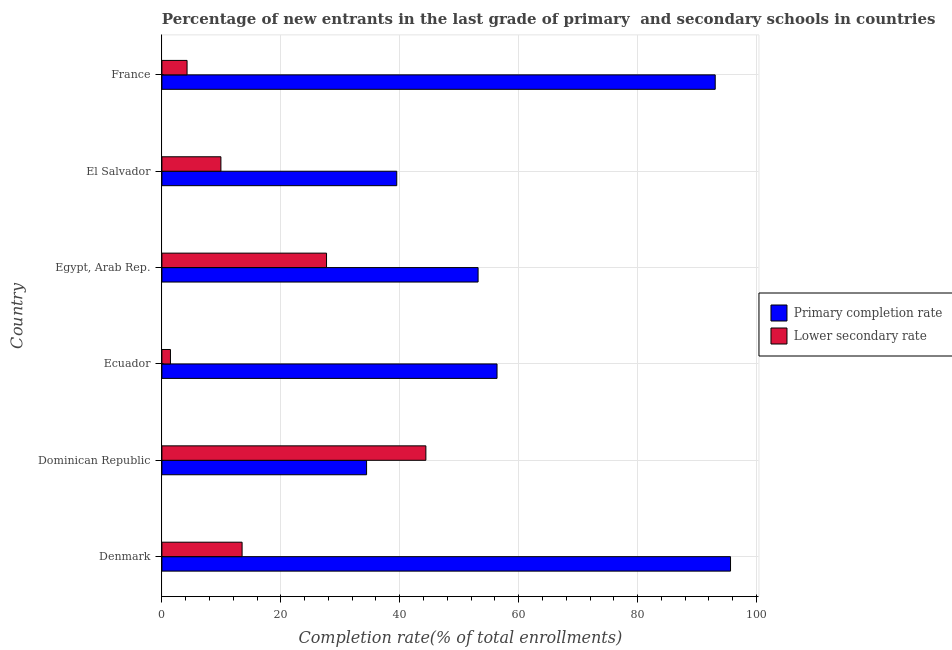How many different coloured bars are there?
Provide a short and direct response. 2. How many groups of bars are there?
Offer a very short reply. 6. Are the number of bars per tick equal to the number of legend labels?
Your answer should be very brief. Yes. What is the completion rate in primary schools in Dominican Republic?
Ensure brevity in your answer.  34.42. Across all countries, what is the maximum completion rate in secondary schools?
Your answer should be very brief. 44.39. Across all countries, what is the minimum completion rate in primary schools?
Your response must be concise. 34.42. In which country was the completion rate in secondary schools maximum?
Your answer should be compact. Dominican Republic. In which country was the completion rate in primary schools minimum?
Offer a terse response. Dominican Republic. What is the total completion rate in primary schools in the graph?
Your response must be concise. 372.14. What is the difference between the completion rate in secondary schools in Ecuador and that in France?
Provide a succinct answer. -2.79. What is the difference between the completion rate in secondary schools in El Salvador and the completion rate in primary schools in France?
Give a very brief answer. -83.13. What is the average completion rate in primary schools per country?
Provide a short and direct response. 62.02. What is the difference between the completion rate in primary schools and completion rate in secondary schools in France?
Your answer should be compact. 88.83. In how many countries, is the completion rate in secondary schools greater than 20 %?
Your response must be concise. 2. What is the ratio of the completion rate in primary schools in Ecuador to that in France?
Your response must be concise. 0.61. Is the completion rate in secondary schools in Ecuador less than that in France?
Your answer should be compact. Yes. What is the difference between the highest and the second highest completion rate in primary schools?
Offer a terse response. 2.58. What is the difference between the highest and the lowest completion rate in primary schools?
Your response must be concise. 61.21. In how many countries, is the completion rate in primary schools greater than the average completion rate in primary schools taken over all countries?
Ensure brevity in your answer.  2. Is the sum of the completion rate in secondary schools in Dominican Republic and Egypt, Arab Rep. greater than the maximum completion rate in primary schools across all countries?
Offer a terse response. No. What does the 1st bar from the top in El Salvador represents?
Make the answer very short. Lower secondary rate. What does the 1st bar from the bottom in Dominican Republic represents?
Offer a terse response. Primary completion rate. How many countries are there in the graph?
Provide a short and direct response. 6. What is the difference between two consecutive major ticks on the X-axis?
Give a very brief answer. 20. Are the values on the major ticks of X-axis written in scientific E-notation?
Give a very brief answer. No. How many legend labels are there?
Give a very brief answer. 2. What is the title of the graph?
Offer a terse response. Percentage of new entrants in the last grade of primary  and secondary schools in countries. Does "Working capital" appear as one of the legend labels in the graph?
Your response must be concise. No. What is the label or title of the X-axis?
Provide a succinct answer. Completion rate(% of total enrollments). What is the Completion rate(% of total enrollments) in Primary completion rate in Denmark?
Your answer should be very brief. 95.63. What is the Completion rate(% of total enrollments) in Lower secondary rate in Denmark?
Your answer should be compact. 13.49. What is the Completion rate(% of total enrollments) in Primary completion rate in Dominican Republic?
Make the answer very short. 34.42. What is the Completion rate(% of total enrollments) in Lower secondary rate in Dominican Republic?
Ensure brevity in your answer.  44.39. What is the Completion rate(% of total enrollments) in Primary completion rate in Ecuador?
Your answer should be compact. 56.36. What is the Completion rate(% of total enrollments) in Lower secondary rate in Ecuador?
Offer a very short reply. 1.44. What is the Completion rate(% of total enrollments) in Primary completion rate in Egypt, Arab Rep.?
Your answer should be very brief. 53.18. What is the Completion rate(% of total enrollments) in Lower secondary rate in Egypt, Arab Rep.?
Offer a very short reply. 27.69. What is the Completion rate(% of total enrollments) of Primary completion rate in El Salvador?
Offer a terse response. 39.5. What is the Completion rate(% of total enrollments) of Lower secondary rate in El Salvador?
Provide a succinct answer. 9.92. What is the Completion rate(% of total enrollments) of Primary completion rate in France?
Make the answer very short. 93.06. What is the Completion rate(% of total enrollments) in Lower secondary rate in France?
Provide a short and direct response. 4.23. Across all countries, what is the maximum Completion rate(% of total enrollments) of Primary completion rate?
Your answer should be very brief. 95.63. Across all countries, what is the maximum Completion rate(% of total enrollments) of Lower secondary rate?
Give a very brief answer. 44.39. Across all countries, what is the minimum Completion rate(% of total enrollments) of Primary completion rate?
Give a very brief answer. 34.42. Across all countries, what is the minimum Completion rate(% of total enrollments) in Lower secondary rate?
Provide a succinct answer. 1.44. What is the total Completion rate(% of total enrollments) of Primary completion rate in the graph?
Provide a succinct answer. 372.14. What is the total Completion rate(% of total enrollments) of Lower secondary rate in the graph?
Make the answer very short. 101.16. What is the difference between the Completion rate(% of total enrollments) of Primary completion rate in Denmark and that in Dominican Republic?
Offer a very short reply. 61.21. What is the difference between the Completion rate(% of total enrollments) of Lower secondary rate in Denmark and that in Dominican Republic?
Provide a short and direct response. -30.91. What is the difference between the Completion rate(% of total enrollments) in Primary completion rate in Denmark and that in Ecuador?
Your response must be concise. 39.27. What is the difference between the Completion rate(% of total enrollments) in Lower secondary rate in Denmark and that in Ecuador?
Your answer should be very brief. 12.05. What is the difference between the Completion rate(% of total enrollments) of Primary completion rate in Denmark and that in Egypt, Arab Rep.?
Give a very brief answer. 42.46. What is the difference between the Completion rate(% of total enrollments) in Lower secondary rate in Denmark and that in Egypt, Arab Rep.?
Offer a terse response. -14.2. What is the difference between the Completion rate(% of total enrollments) in Primary completion rate in Denmark and that in El Salvador?
Provide a succinct answer. 56.13. What is the difference between the Completion rate(% of total enrollments) of Lower secondary rate in Denmark and that in El Salvador?
Your answer should be very brief. 3.56. What is the difference between the Completion rate(% of total enrollments) of Primary completion rate in Denmark and that in France?
Offer a very short reply. 2.57. What is the difference between the Completion rate(% of total enrollments) in Lower secondary rate in Denmark and that in France?
Offer a terse response. 9.25. What is the difference between the Completion rate(% of total enrollments) of Primary completion rate in Dominican Republic and that in Ecuador?
Provide a short and direct response. -21.94. What is the difference between the Completion rate(% of total enrollments) of Lower secondary rate in Dominican Republic and that in Ecuador?
Provide a succinct answer. 42.95. What is the difference between the Completion rate(% of total enrollments) of Primary completion rate in Dominican Republic and that in Egypt, Arab Rep.?
Give a very brief answer. -18.75. What is the difference between the Completion rate(% of total enrollments) in Lower secondary rate in Dominican Republic and that in Egypt, Arab Rep.?
Provide a succinct answer. 16.71. What is the difference between the Completion rate(% of total enrollments) in Primary completion rate in Dominican Republic and that in El Salvador?
Offer a very short reply. -5.07. What is the difference between the Completion rate(% of total enrollments) in Lower secondary rate in Dominican Republic and that in El Salvador?
Provide a succinct answer. 34.47. What is the difference between the Completion rate(% of total enrollments) of Primary completion rate in Dominican Republic and that in France?
Offer a terse response. -58.63. What is the difference between the Completion rate(% of total enrollments) in Lower secondary rate in Dominican Republic and that in France?
Provide a succinct answer. 40.16. What is the difference between the Completion rate(% of total enrollments) in Primary completion rate in Ecuador and that in Egypt, Arab Rep.?
Make the answer very short. 3.18. What is the difference between the Completion rate(% of total enrollments) of Lower secondary rate in Ecuador and that in Egypt, Arab Rep.?
Keep it short and to the point. -26.25. What is the difference between the Completion rate(% of total enrollments) in Primary completion rate in Ecuador and that in El Salvador?
Provide a short and direct response. 16.86. What is the difference between the Completion rate(% of total enrollments) of Lower secondary rate in Ecuador and that in El Salvador?
Your response must be concise. -8.49. What is the difference between the Completion rate(% of total enrollments) of Primary completion rate in Ecuador and that in France?
Make the answer very short. -36.7. What is the difference between the Completion rate(% of total enrollments) in Lower secondary rate in Ecuador and that in France?
Offer a very short reply. -2.79. What is the difference between the Completion rate(% of total enrollments) of Primary completion rate in Egypt, Arab Rep. and that in El Salvador?
Ensure brevity in your answer.  13.68. What is the difference between the Completion rate(% of total enrollments) of Lower secondary rate in Egypt, Arab Rep. and that in El Salvador?
Provide a short and direct response. 17.76. What is the difference between the Completion rate(% of total enrollments) in Primary completion rate in Egypt, Arab Rep. and that in France?
Keep it short and to the point. -39.88. What is the difference between the Completion rate(% of total enrollments) of Lower secondary rate in Egypt, Arab Rep. and that in France?
Your answer should be compact. 23.46. What is the difference between the Completion rate(% of total enrollments) in Primary completion rate in El Salvador and that in France?
Keep it short and to the point. -53.56. What is the difference between the Completion rate(% of total enrollments) in Lower secondary rate in El Salvador and that in France?
Your answer should be very brief. 5.69. What is the difference between the Completion rate(% of total enrollments) of Primary completion rate in Denmark and the Completion rate(% of total enrollments) of Lower secondary rate in Dominican Republic?
Offer a very short reply. 51.24. What is the difference between the Completion rate(% of total enrollments) in Primary completion rate in Denmark and the Completion rate(% of total enrollments) in Lower secondary rate in Ecuador?
Provide a short and direct response. 94.19. What is the difference between the Completion rate(% of total enrollments) of Primary completion rate in Denmark and the Completion rate(% of total enrollments) of Lower secondary rate in Egypt, Arab Rep.?
Your response must be concise. 67.94. What is the difference between the Completion rate(% of total enrollments) of Primary completion rate in Denmark and the Completion rate(% of total enrollments) of Lower secondary rate in El Salvador?
Keep it short and to the point. 85.71. What is the difference between the Completion rate(% of total enrollments) of Primary completion rate in Denmark and the Completion rate(% of total enrollments) of Lower secondary rate in France?
Make the answer very short. 91.4. What is the difference between the Completion rate(% of total enrollments) in Primary completion rate in Dominican Republic and the Completion rate(% of total enrollments) in Lower secondary rate in Ecuador?
Provide a short and direct response. 32.98. What is the difference between the Completion rate(% of total enrollments) of Primary completion rate in Dominican Republic and the Completion rate(% of total enrollments) of Lower secondary rate in Egypt, Arab Rep.?
Ensure brevity in your answer.  6.73. What is the difference between the Completion rate(% of total enrollments) in Primary completion rate in Dominican Republic and the Completion rate(% of total enrollments) in Lower secondary rate in El Salvador?
Keep it short and to the point. 24.5. What is the difference between the Completion rate(% of total enrollments) in Primary completion rate in Dominican Republic and the Completion rate(% of total enrollments) in Lower secondary rate in France?
Ensure brevity in your answer.  30.19. What is the difference between the Completion rate(% of total enrollments) of Primary completion rate in Ecuador and the Completion rate(% of total enrollments) of Lower secondary rate in Egypt, Arab Rep.?
Make the answer very short. 28.67. What is the difference between the Completion rate(% of total enrollments) of Primary completion rate in Ecuador and the Completion rate(% of total enrollments) of Lower secondary rate in El Salvador?
Make the answer very short. 46.44. What is the difference between the Completion rate(% of total enrollments) of Primary completion rate in Ecuador and the Completion rate(% of total enrollments) of Lower secondary rate in France?
Offer a terse response. 52.13. What is the difference between the Completion rate(% of total enrollments) of Primary completion rate in Egypt, Arab Rep. and the Completion rate(% of total enrollments) of Lower secondary rate in El Salvador?
Offer a very short reply. 43.25. What is the difference between the Completion rate(% of total enrollments) of Primary completion rate in Egypt, Arab Rep. and the Completion rate(% of total enrollments) of Lower secondary rate in France?
Your answer should be compact. 48.94. What is the difference between the Completion rate(% of total enrollments) in Primary completion rate in El Salvador and the Completion rate(% of total enrollments) in Lower secondary rate in France?
Provide a succinct answer. 35.27. What is the average Completion rate(% of total enrollments) in Primary completion rate per country?
Offer a terse response. 62.02. What is the average Completion rate(% of total enrollments) in Lower secondary rate per country?
Keep it short and to the point. 16.86. What is the difference between the Completion rate(% of total enrollments) in Primary completion rate and Completion rate(% of total enrollments) in Lower secondary rate in Denmark?
Make the answer very short. 82.15. What is the difference between the Completion rate(% of total enrollments) of Primary completion rate and Completion rate(% of total enrollments) of Lower secondary rate in Dominican Republic?
Make the answer very short. -9.97. What is the difference between the Completion rate(% of total enrollments) of Primary completion rate and Completion rate(% of total enrollments) of Lower secondary rate in Ecuador?
Make the answer very short. 54.92. What is the difference between the Completion rate(% of total enrollments) in Primary completion rate and Completion rate(% of total enrollments) in Lower secondary rate in Egypt, Arab Rep.?
Offer a very short reply. 25.49. What is the difference between the Completion rate(% of total enrollments) in Primary completion rate and Completion rate(% of total enrollments) in Lower secondary rate in El Salvador?
Your answer should be very brief. 29.57. What is the difference between the Completion rate(% of total enrollments) of Primary completion rate and Completion rate(% of total enrollments) of Lower secondary rate in France?
Your answer should be very brief. 88.82. What is the ratio of the Completion rate(% of total enrollments) in Primary completion rate in Denmark to that in Dominican Republic?
Provide a short and direct response. 2.78. What is the ratio of the Completion rate(% of total enrollments) of Lower secondary rate in Denmark to that in Dominican Republic?
Offer a terse response. 0.3. What is the ratio of the Completion rate(% of total enrollments) of Primary completion rate in Denmark to that in Ecuador?
Ensure brevity in your answer.  1.7. What is the ratio of the Completion rate(% of total enrollments) of Lower secondary rate in Denmark to that in Ecuador?
Your answer should be compact. 9.37. What is the ratio of the Completion rate(% of total enrollments) in Primary completion rate in Denmark to that in Egypt, Arab Rep.?
Your response must be concise. 1.8. What is the ratio of the Completion rate(% of total enrollments) of Lower secondary rate in Denmark to that in Egypt, Arab Rep.?
Provide a succinct answer. 0.49. What is the ratio of the Completion rate(% of total enrollments) of Primary completion rate in Denmark to that in El Salvador?
Make the answer very short. 2.42. What is the ratio of the Completion rate(% of total enrollments) of Lower secondary rate in Denmark to that in El Salvador?
Your response must be concise. 1.36. What is the ratio of the Completion rate(% of total enrollments) of Primary completion rate in Denmark to that in France?
Your response must be concise. 1.03. What is the ratio of the Completion rate(% of total enrollments) of Lower secondary rate in Denmark to that in France?
Your answer should be compact. 3.19. What is the ratio of the Completion rate(% of total enrollments) of Primary completion rate in Dominican Republic to that in Ecuador?
Offer a terse response. 0.61. What is the ratio of the Completion rate(% of total enrollments) of Lower secondary rate in Dominican Republic to that in Ecuador?
Offer a very short reply. 30.85. What is the ratio of the Completion rate(% of total enrollments) of Primary completion rate in Dominican Republic to that in Egypt, Arab Rep.?
Provide a short and direct response. 0.65. What is the ratio of the Completion rate(% of total enrollments) in Lower secondary rate in Dominican Republic to that in Egypt, Arab Rep.?
Offer a terse response. 1.6. What is the ratio of the Completion rate(% of total enrollments) of Primary completion rate in Dominican Republic to that in El Salvador?
Offer a very short reply. 0.87. What is the ratio of the Completion rate(% of total enrollments) in Lower secondary rate in Dominican Republic to that in El Salvador?
Offer a terse response. 4.47. What is the ratio of the Completion rate(% of total enrollments) of Primary completion rate in Dominican Republic to that in France?
Offer a very short reply. 0.37. What is the ratio of the Completion rate(% of total enrollments) of Lower secondary rate in Dominican Republic to that in France?
Ensure brevity in your answer.  10.49. What is the ratio of the Completion rate(% of total enrollments) in Primary completion rate in Ecuador to that in Egypt, Arab Rep.?
Ensure brevity in your answer.  1.06. What is the ratio of the Completion rate(% of total enrollments) of Lower secondary rate in Ecuador to that in Egypt, Arab Rep.?
Make the answer very short. 0.05. What is the ratio of the Completion rate(% of total enrollments) in Primary completion rate in Ecuador to that in El Salvador?
Your answer should be very brief. 1.43. What is the ratio of the Completion rate(% of total enrollments) in Lower secondary rate in Ecuador to that in El Salvador?
Provide a short and direct response. 0.14. What is the ratio of the Completion rate(% of total enrollments) in Primary completion rate in Ecuador to that in France?
Give a very brief answer. 0.61. What is the ratio of the Completion rate(% of total enrollments) in Lower secondary rate in Ecuador to that in France?
Make the answer very short. 0.34. What is the ratio of the Completion rate(% of total enrollments) in Primary completion rate in Egypt, Arab Rep. to that in El Salvador?
Give a very brief answer. 1.35. What is the ratio of the Completion rate(% of total enrollments) in Lower secondary rate in Egypt, Arab Rep. to that in El Salvador?
Your answer should be compact. 2.79. What is the ratio of the Completion rate(% of total enrollments) of Primary completion rate in Egypt, Arab Rep. to that in France?
Make the answer very short. 0.57. What is the ratio of the Completion rate(% of total enrollments) in Lower secondary rate in Egypt, Arab Rep. to that in France?
Make the answer very short. 6.54. What is the ratio of the Completion rate(% of total enrollments) of Primary completion rate in El Salvador to that in France?
Give a very brief answer. 0.42. What is the ratio of the Completion rate(% of total enrollments) in Lower secondary rate in El Salvador to that in France?
Offer a very short reply. 2.35. What is the difference between the highest and the second highest Completion rate(% of total enrollments) of Primary completion rate?
Provide a succinct answer. 2.57. What is the difference between the highest and the second highest Completion rate(% of total enrollments) of Lower secondary rate?
Your response must be concise. 16.71. What is the difference between the highest and the lowest Completion rate(% of total enrollments) of Primary completion rate?
Provide a short and direct response. 61.21. What is the difference between the highest and the lowest Completion rate(% of total enrollments) in Lower secondary rate?
Provide a short and direct response. 42.95. 